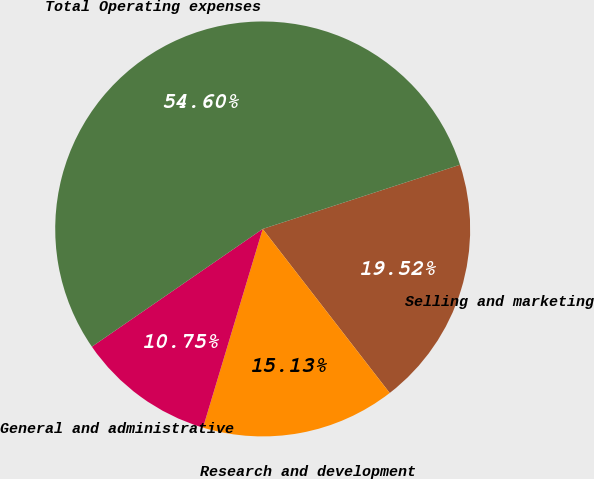Convert chart. <chart><loc_0><loc_0><loc_500><loc_500><pie_chart><fcel>Selling and marketing<fcel>Research and development<fcel>General and administrative<fcel>Total Operating expenses<nl><fcel>19.52%<fcel>15.13%<fcel>10.75%<fcel>54.6%<nl></chart> 